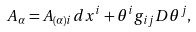Convert formula to latex. <formula><loc_0><loc_0><loc_500><loc_500>A _ { \alpha } = A _ { ( \alpha ) i } d x ^ { i } + \theta ^ { i } g _ { i j } D \theta ^ { j } ,</formula> 